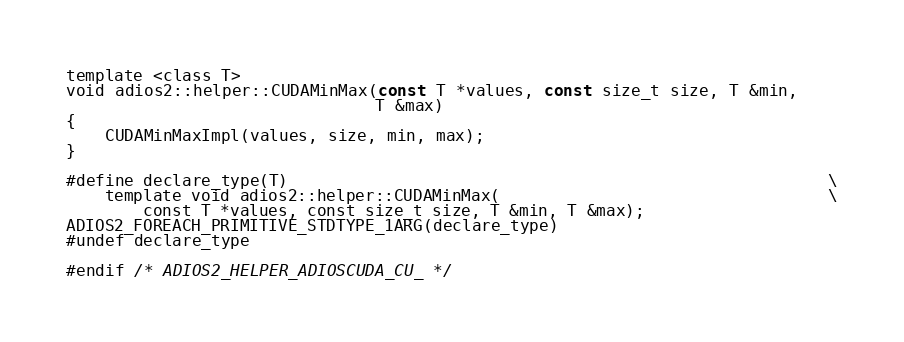Convert code to text. <code><loc_0><loc_0><loc_500><loc_500><_Cuda_>
template <class T>
void adios2::helper::CUDAMinMax(const T *values, const size_t size, T &min,
                                T &max)
{
    CUDAMinMaxImpl(values, size, min, max);
}

#define declare_type(T)                                                        \
    template void adios2::helper::CUDAMinMax(                                  \
        const T *values, const size_t size, T &min, T &max);
ADIOS2_FOREACH_PRIMITIVE_STDTYPE_1ARG(declare_type)
#undef declare_type

#endif /* ADIOS2_HELPER_ADIOSCUDA_CU_ */
</code> 